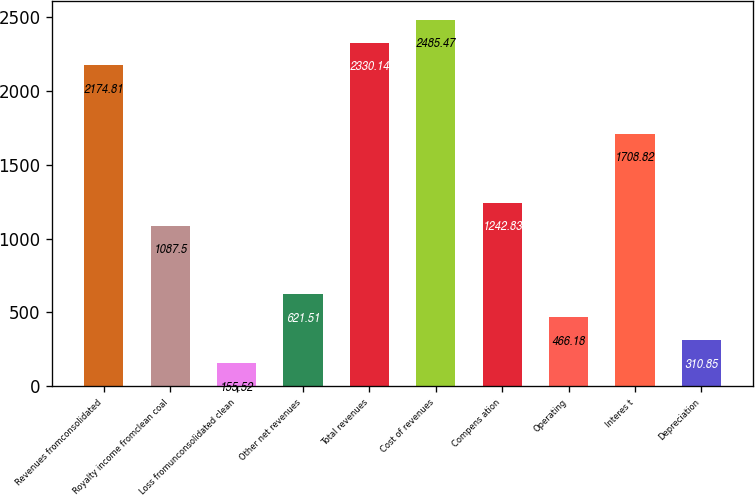Convert chart. <chart><loc_0><loc_0><loc_500><loc_500><bar_chart><fcel>Revenues fromconsolidated<fcel>Royalty income fromclean coal<fcel>Loss fromunconsolidated clean<fcel>Other net revenues<fcel>Total revenues<fcel>Cost of revenues<fcel>Compens ation<fcel>Operating<fcel>Interes t<fcel>Depreciation<nl><fcel>2174.81<fcel>1087.5<fcel>155.52<fcel>621.51<fcel>2330.14<fcel>2485.47<fcel>1242.83<fcel>466.18<fcel>1708.82<fcel>310.85<nl></chart> 